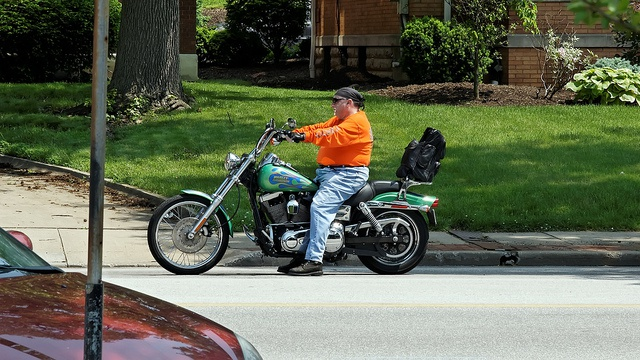Describe the objects in this image and their specific colors. I can see motorcycle in darkgreen, black, gray, darkgray, and lightgray tones, car in darkgreen, maroon, gray, darkgray, and black tones, people in darkgreen, black, red, lightblue, and brown tones, and backpack in darkgreen, black, and gray tones in this image. 